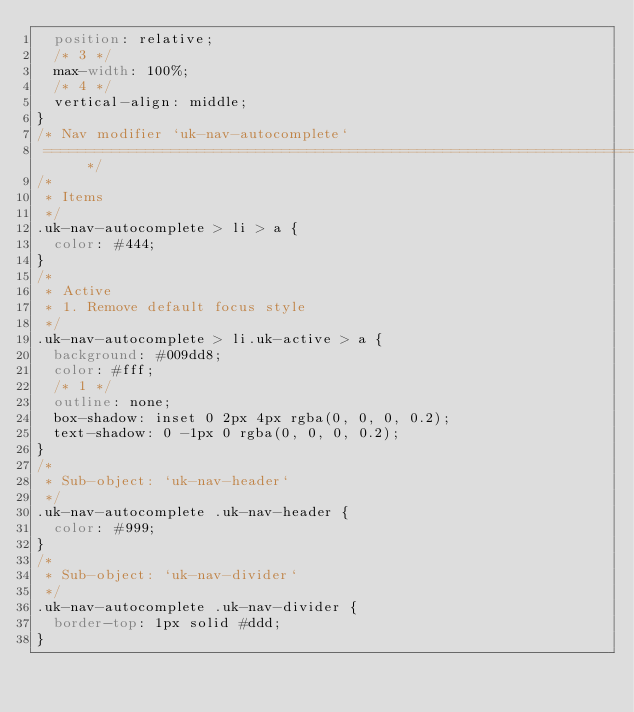<code> <loc_0><loc_0><loc_500><loc_500><_CSS_>  position: relative;
  /* 3 */
  max-width: 100%;
  /* 4 */
  vertical-align: middle;
}
/* Nav modifier `uk-nav-autocomplete`
 ========================================================================== */
/*
 * Items
 */
.uk-nav-autocomplete > li > a {
  color: #444;
}
/*
 * Active
 * 1. Remove default focus style
 */
.uk-nav-autocomplete > li.uk-active > a {
  background: #009dd8;
  color: #fff;
  /* 1 */
  outline: none;
  box-shadow: inset 0 2px 4px rgba(0, 0, 0, 0.2);
  text-shadow: 0 -1px 0 rgba(0, 0, 0, 0.2);
}
/*
 * Sub-object: `uk-nav-header`
 */
.uk-nav-autocomplete .uk-nav-header {
  color: #999;
}
/*
 * Sub-object: `uk-nav-divider`
 */
.uk-nav-autocomplete .uk-nav-divider {
  border-top: 1px solid #ddd;
}
</code> 